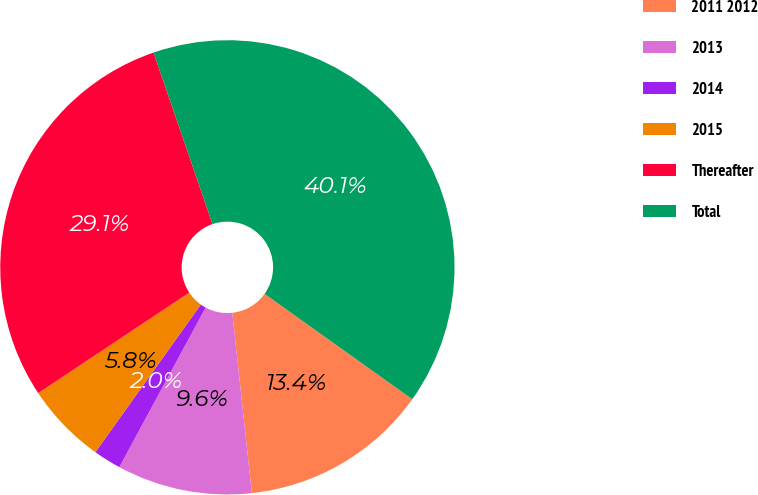Convert chart to OTSL. <chart><loc_0><loc_0><loc_500><loc_500><pie_chart><fcel>2011 2012<fcel>2013<fcel>2014<fcel>2015<fcel>Thereafter<fcel>Total<nl><fcel>13.42%<fcel>9.61%<fcel>1.98%<fcel>5.79%<fcel>29.07%<fcel>40.13%<nl></chart> 